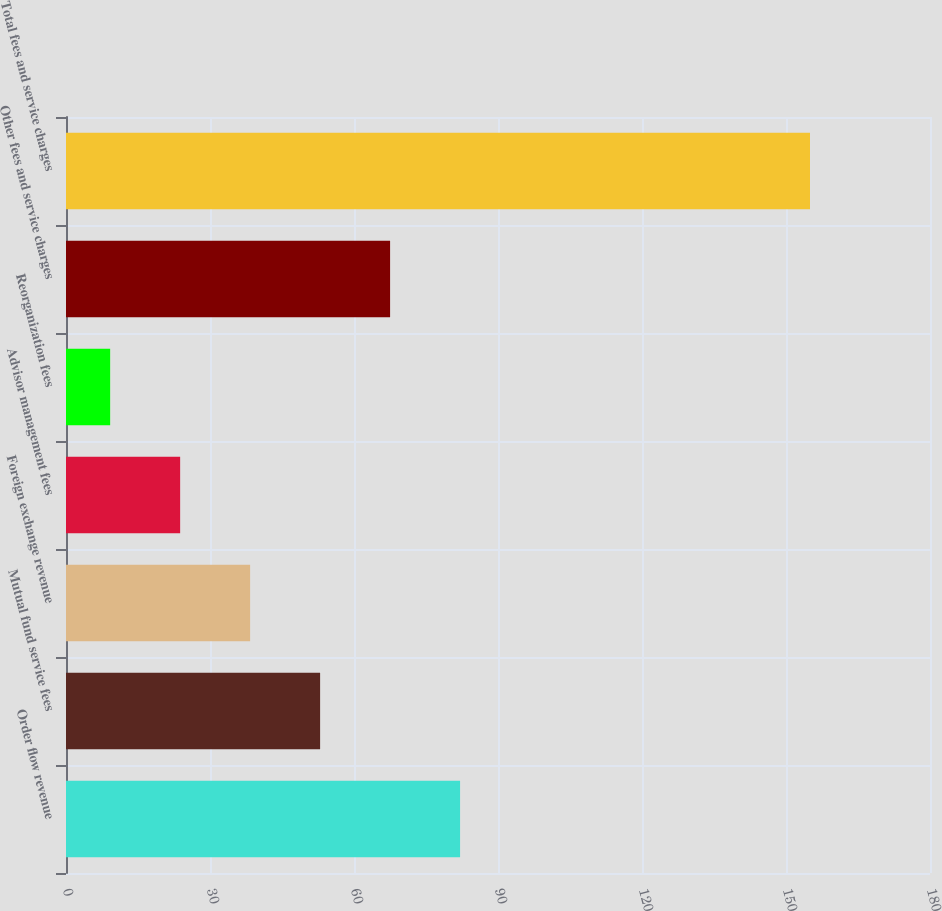<chart> <loc_0><loc_0><loc_500><loc_500><bar_chart><fcel>Order flow revenue<fcel>Mutual fund service fees<fcel>Foreign exchange revenue<fcel>Advisor management fees<fcel>Reorganization fees<fcel>Other fees and service charges<fcel>Total fees and service charges<nl><fcel>82.1<fcel>52.94<fcel>38.36<fcel>23.78<fcel>9.2<fcel>67.52<fcel>155<nl></chart> 